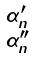Convert formula to latex. <formula><loc_0><loc_0><loc_500><loc_500>\begin{smallmatrix} \alpha ^ { \prime } _ { n } \\ \alpha ^ { \prime \prime } _ { n } \end{smallmatrix}</formula> 